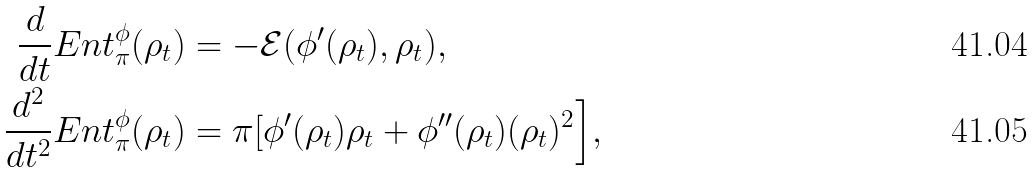Convert formula to latex. <formula><loc_0><loc_0><loc_500><loc_500>\frac { d } { d t } E n t _ { \pi } ^ { \phi } ( \rho _ { t } ) & = - { \mathcal { E } } ( \phi ^ { \prime } ( \rho _ { t } ) , \rho _ { t } ) , \\ \frac { d ^ { 2 } } { d t ^ { 2 } } E n t _ { \pi } ^ { \phi } ( \rho _ { t } ) & = \pi [ \L \phi ^ { \prime } ( \rho _ { t } ) \L \rho _ { t } + \phi ^ { \prime \prime } ( \rho _ { t } ) ( \L \rho _ { t } ) ^ { 2 } \Big ] ,</formula> 